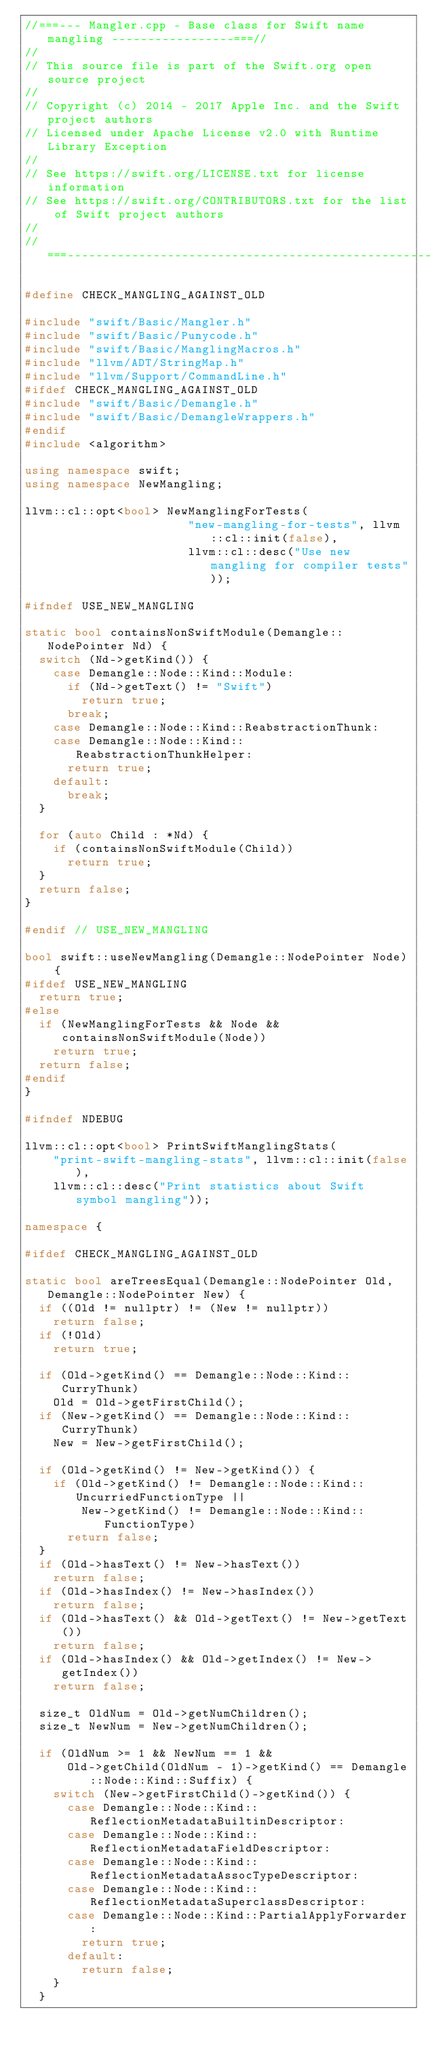Convert code to text. <code><loc_0><loc_0><loc_500><loc_500><_C++_>//===--- Mangler.cpp - Base class for Swift name mangling -----------------===//
//
// This source file is part of the Swift.org open source project
//
// Copyright (c) 2014 - 2017 Apple Inc. and the Swift project authors
// Licensed under Apache License v2.0 with Runtime Library Exception
//
// See https://swift.org/LICENSE.txt for license information
// See https://swift.org/CONTRIBUTORS.txt for the list of Swift project authors
//
//===----------------------------------------------------------------------===//

#define CHECK_MANGLING_AGAINST_OLD

#include "swift/Basic/Mangler.h"
#include "swift/Basic/Punycode.h"
#include "swift/Basic/ManglingMacros.h"
#include "llvm/ADT/StringMap.h"
#include "llvm/Support/CommandLine.h"
#ifdef CHECK_MANGLING_AGAINST_OLD
#include "swift/Basic/Demangle.h"
#include "swift/Basic/DemangleWrappers.h"
#endif
#include <algorithm>

using namespace swift;
using namespace NewMangling;

llvm::cl::opt<bool> NewManglingForTests(
                       "new-mangling-for-tests", llvm::cl::init(false),
                       llvm::cl::desc("Use new mangling for compiler tests"));

#ifndef USE_NEW_MANGLING

static bool containsNonSwiftModule(Demangle::NodePointer Nd) {
  switch (Nd->getKind()) {
    case Demangle::Node::Kind::Module:
      if (Nd->getText() != "Swift")
        return true;
      break;
    case Demangle::Node::Kind::ReabstractionThunk:
    case Demangle::Node::Kind::ReabstractionThunkHelper:
      return true;
    default:
      break;
  }

  for (auto Child : *Nd) {
    if (containsNonSwiftModule(Child))
      return true;
  }
  return false;
}

#endif // USE_NEW_MANGLING

bool swift::useNewMangling(Demangle::NodePointer Node) {
#ifdef USE_NEW_MANGLING
  return true;
#else
  if (NewManglingForTests && Node && containsNonSwiftModule(Node))
    return true;
  return false;
#endif
}

#ifndef NDEBUG

llvm::cl::opt<bool> PrintSwiftManglingStats(
    "print-swift-mangling-stats", llvm::cl::init(false),
    llvm::cl::desc("Print statistics about Swift symbol mangling"));

namespace {

#ifdef CHECK_MANGLING_AGAINST_OLD

static bool areTreesEqual(Demangle::NodePointer Old, Demangle::NodePointer New) {
  if ((Old != nullptr) != (New != nullptr))
    return false;
  if (!Old)
    return true;

  if (Old->getKind() == Demangle::Node::Kind::CurryThunk)
    Old = Old->getFirstChild();
  if (New->getKind() == Demangle::Node::Kind::CurryThunk)
    New = New->getFirstChild();

  if (Old->getKind() != New->getKind()) {
    if (Old->getKind() != Demangle::Node::Kind::UncurriedFunctionType ||
        New->getKind() != Demangle::Node::Kind::FunctionType)
      return false;
  }
  if (Old->hasText() != New->hasText())
    return false;
  if (Old->hasIndex() != New->hasIndex())
    return false;
  if (Old->hasText() && Old->getText() != New->getText())
    return false;
  if (Old->hasIndex() && Old->getIndex() != New->getIndex())
    return false;

  size_t OldNum = Old->getNumChildren();
  size_t NewNum = New->getNumChildren();

  if (OldNum >= 1 && NewNum == 1 &&
      Old->getChild(OldNum - 1)->getKind() == Demangle::Node::Kind::Suffix) {
    switch (New->getFirstChild()->getKind()) {
      case Demangle::Node::Kind::ReflectionMetadataBuiltinDescriptor:
      case Demangle::Node::Kind::ReflectionMetadataFieldDescriptor:
      case Demangle::Node::Kind::ReflectionMetadataAssocTypeDescriptor:
      case Demangle::Node::Kind::ReflectionMetadataSuperclassDescriptor:
      case Demangle::Node::Kind::PartialApplyForwarder:
        return true;
      default:
        return false;
    }
  }
</code> 